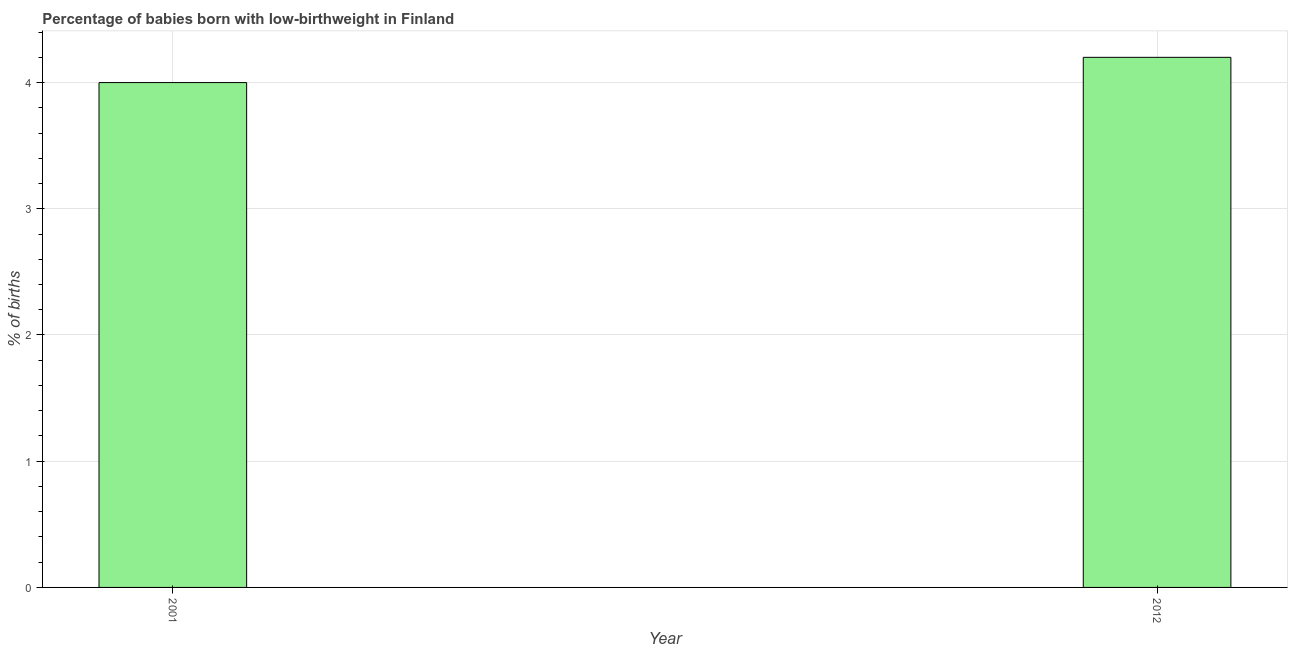What is the title of the graph?
Offer a very short reply. Percentage of babies born with low-birthweight in Finland. What is the label or title of the Y-axis?
Offer a terse response. % of births. What is the percentage of babies who were born with low-birthweight in 2012?
Ensure brevity in your answer.  4.2. Across all years, what is the minimum percentage of babies who were born with low-birthweight?
Your answer should be compact. 4. In which year was the percentage of babies who were born with low-birthweight minimum?
Your answer should be very brief. 2001. What is the sum of the percentage of babies who were born with low-birthweight?
Your answer should be very brief. 8.2. What is the median percentage of babies who were born with low-birthweight?
Provide a succinct answer. 4.1. In how many years, is the percentage of babies who were born with low-birthweight greater than 3.2 %?
Keep it short and to the point. 2. How many bars are there?
Keep it short and to the point. 2. How many years are there in the graph?
Ensure brevity in your answer.  2. 